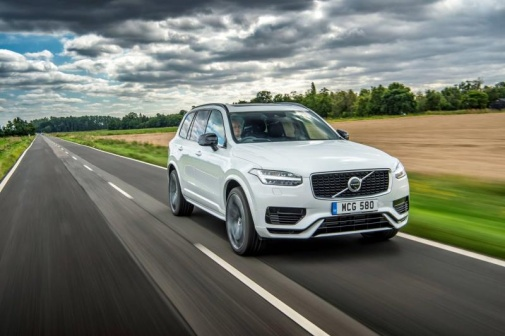Imagine the car in the image could talk. What might it be saying? If the car in the image could talk, it might say, 'Ah, the open road! There's nothing like the fresh air and the thrill of a post-rain drive across the countryside. Every drop of rain makes this journey more refreshing and rejuvenating. Let's embrace the adventure that lies ahead!' 